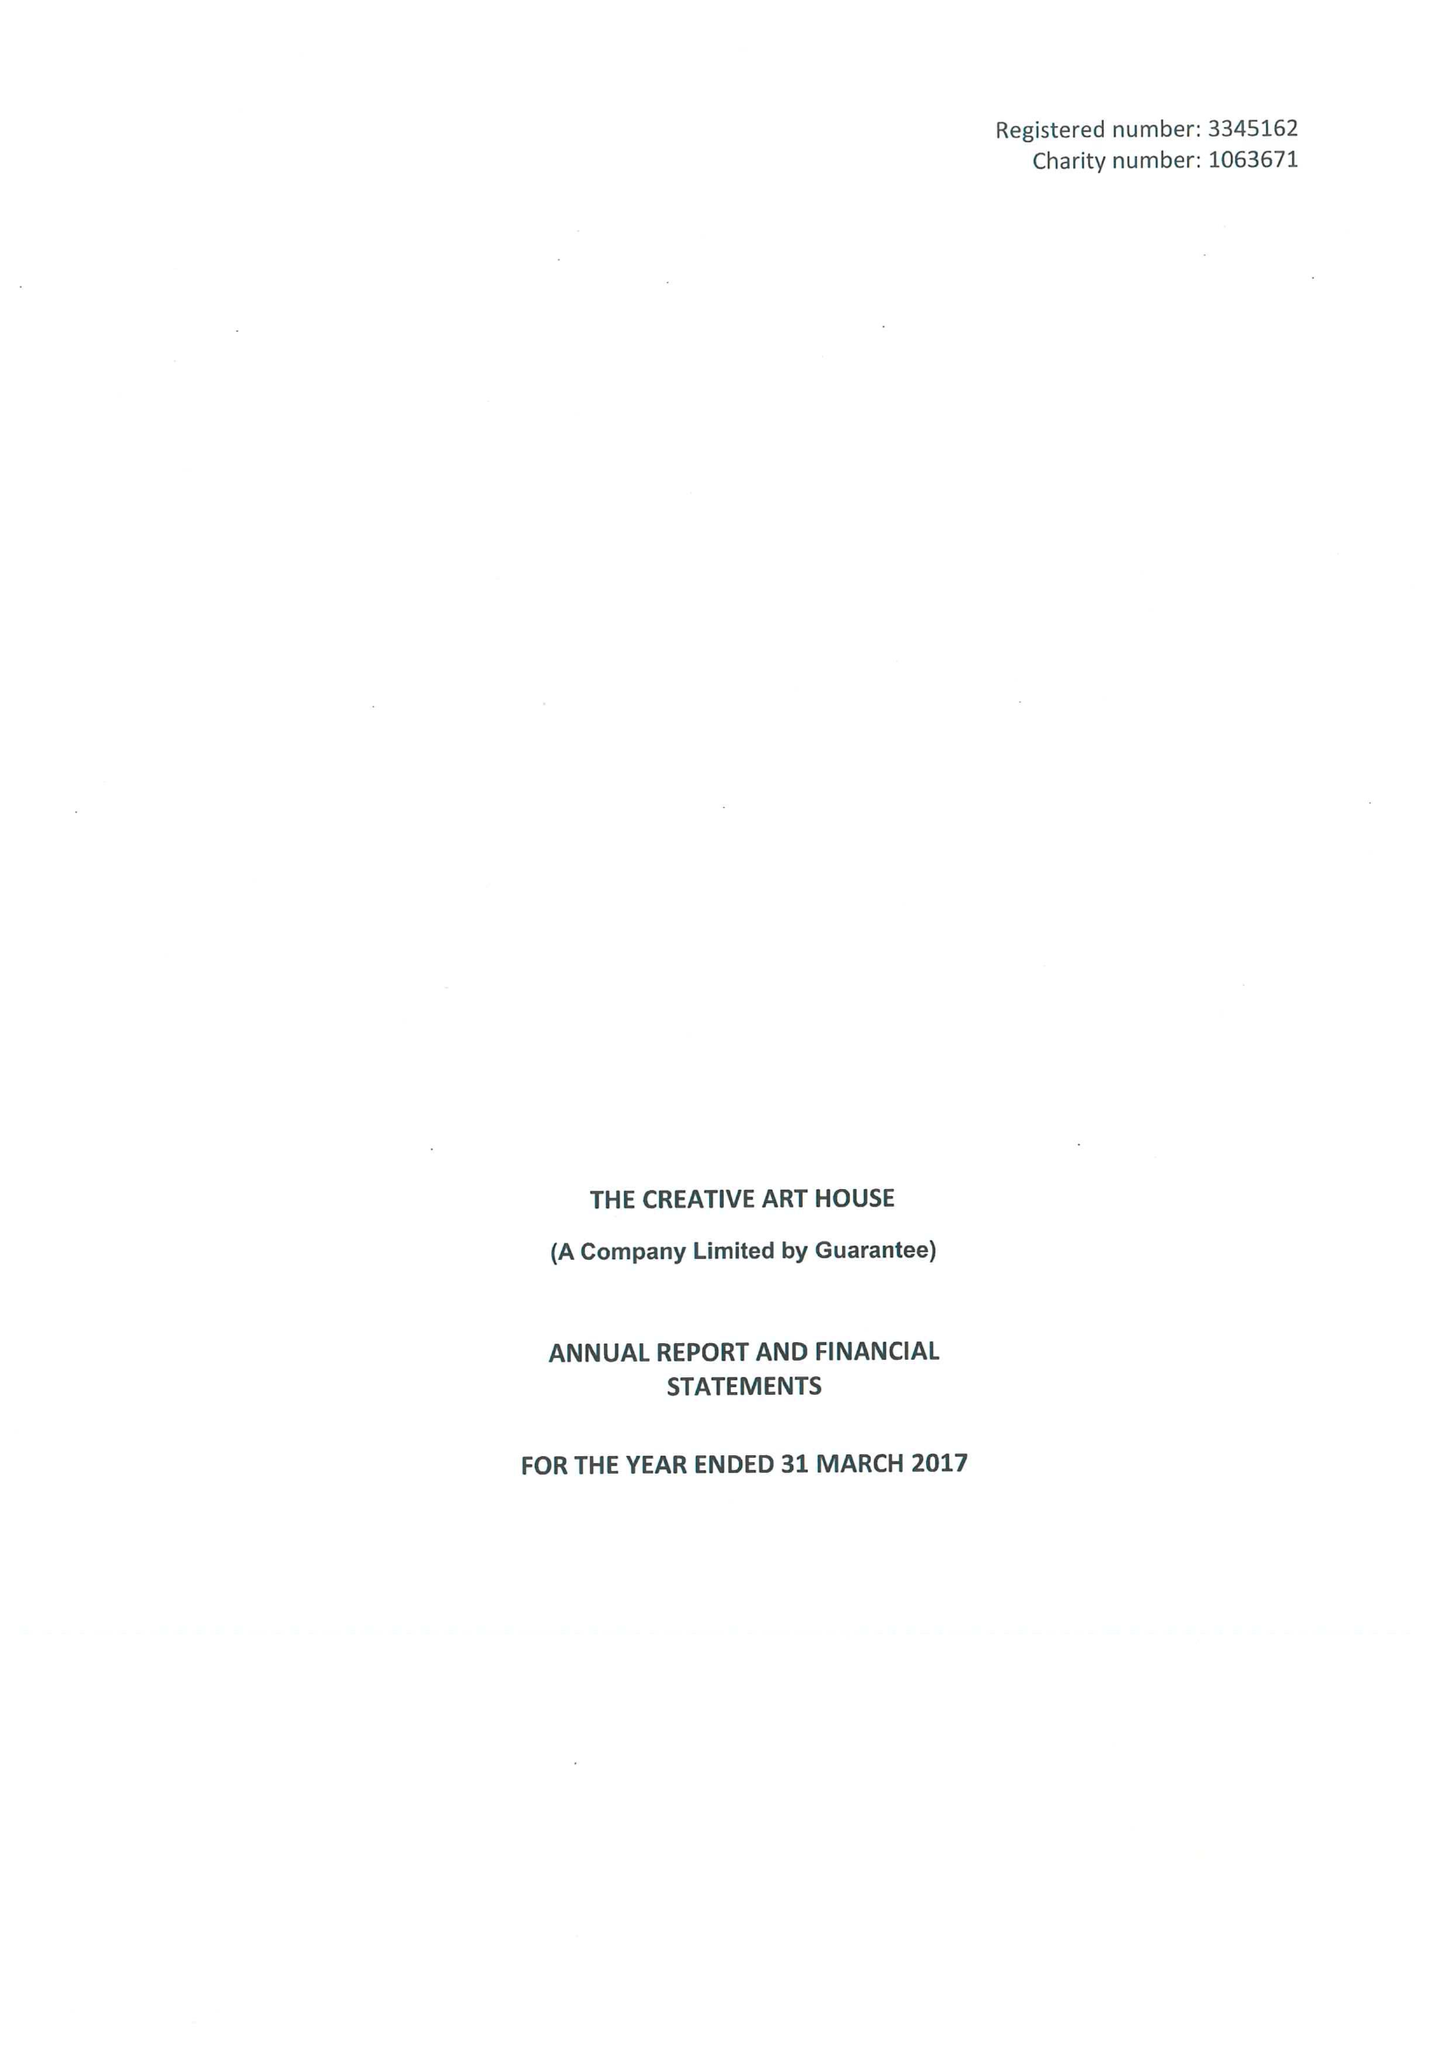What is the value for the spending_annually_in_british_pounds?
Answer the question using a single word or phrase. 481887.00 